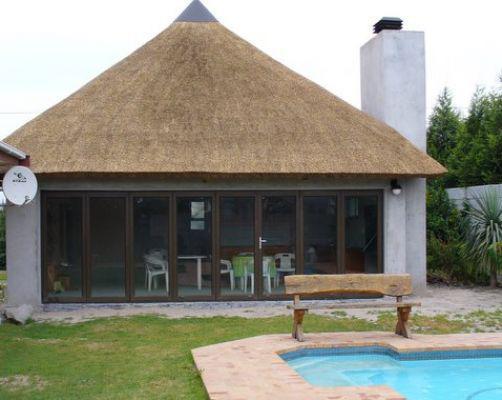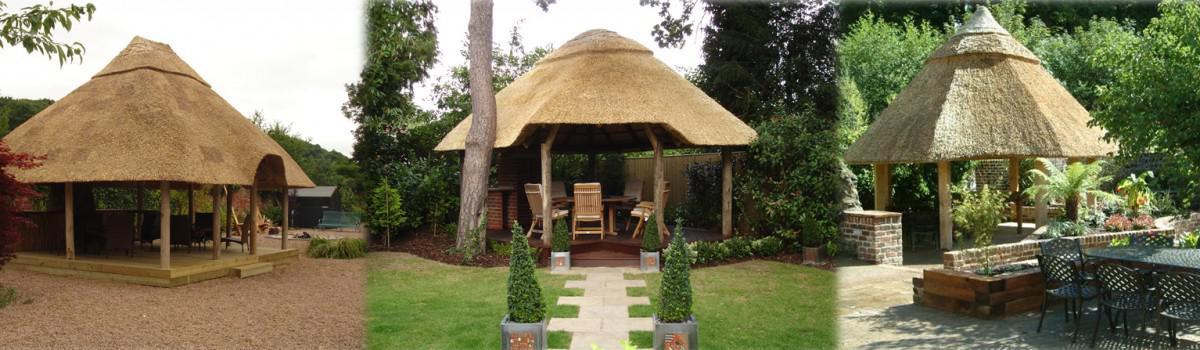The first image is the image on the left, the second image is the image on the right. Evaluate the accuracy of this statement regarding the images: "In one of the images, you can see a man-made pool just in front of the dwelling.". Is it true? Answer yes or no. Yes. The first image is the image on the left, the second image is the image on the right. Analyze the images presented: Is the assertion "There is a pool in one image and not the other." valid? Answer yes or no. Yes. 